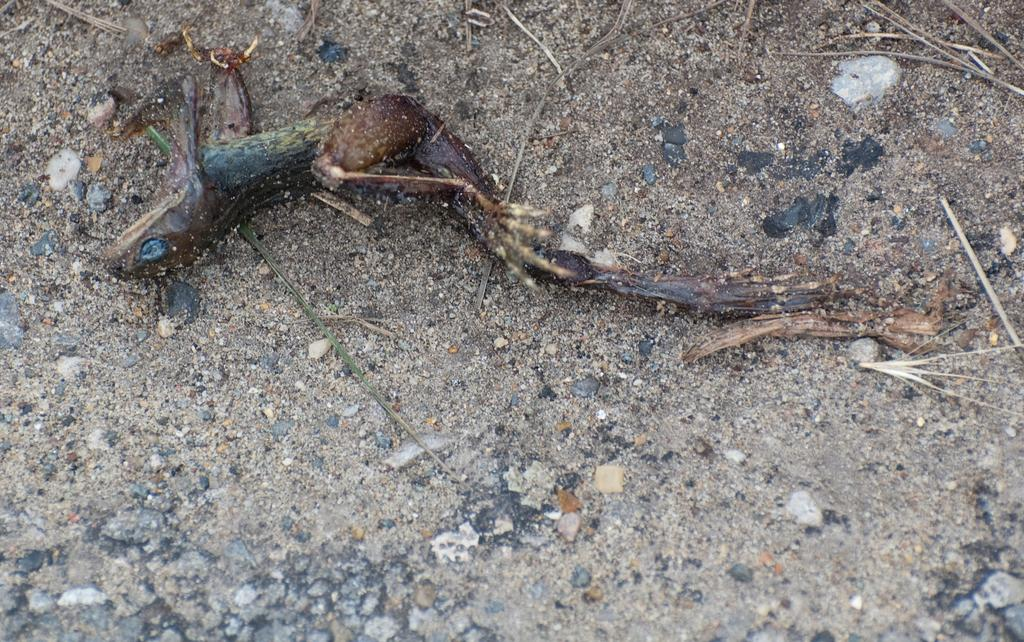What type of surface can be seen in the image? There is ground visible in the image. What is the main subject of the image? There is a dead reptile in the image. What colors are present on the reptile? The reptile is green, brown, and cream in color. What type of brick is being used to build the reptile's home in the image? There is no brick or home visible in the image; it only features a dead reptile on the ground. Can you tell me the name of the reptile's friend in the image? There are no other living creatures or friends present in the image; it only features a dead reptile. 